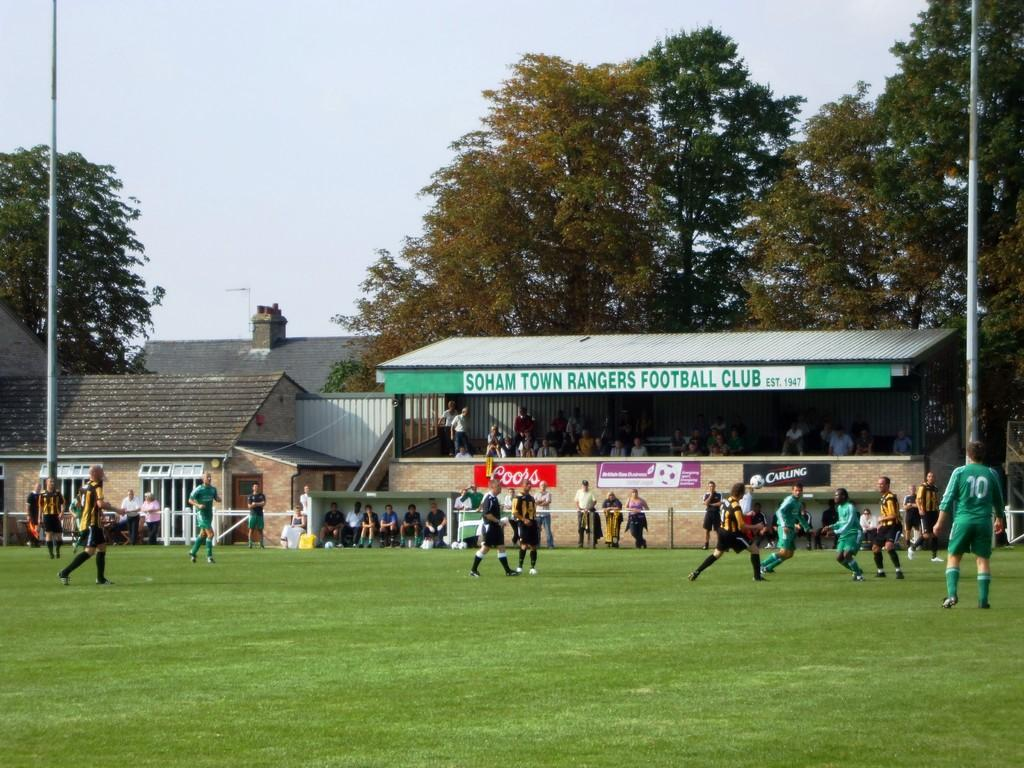Provide a one-sentence caption for the provided image. A small section of bleachers is identified by a sign reading Football Club. 